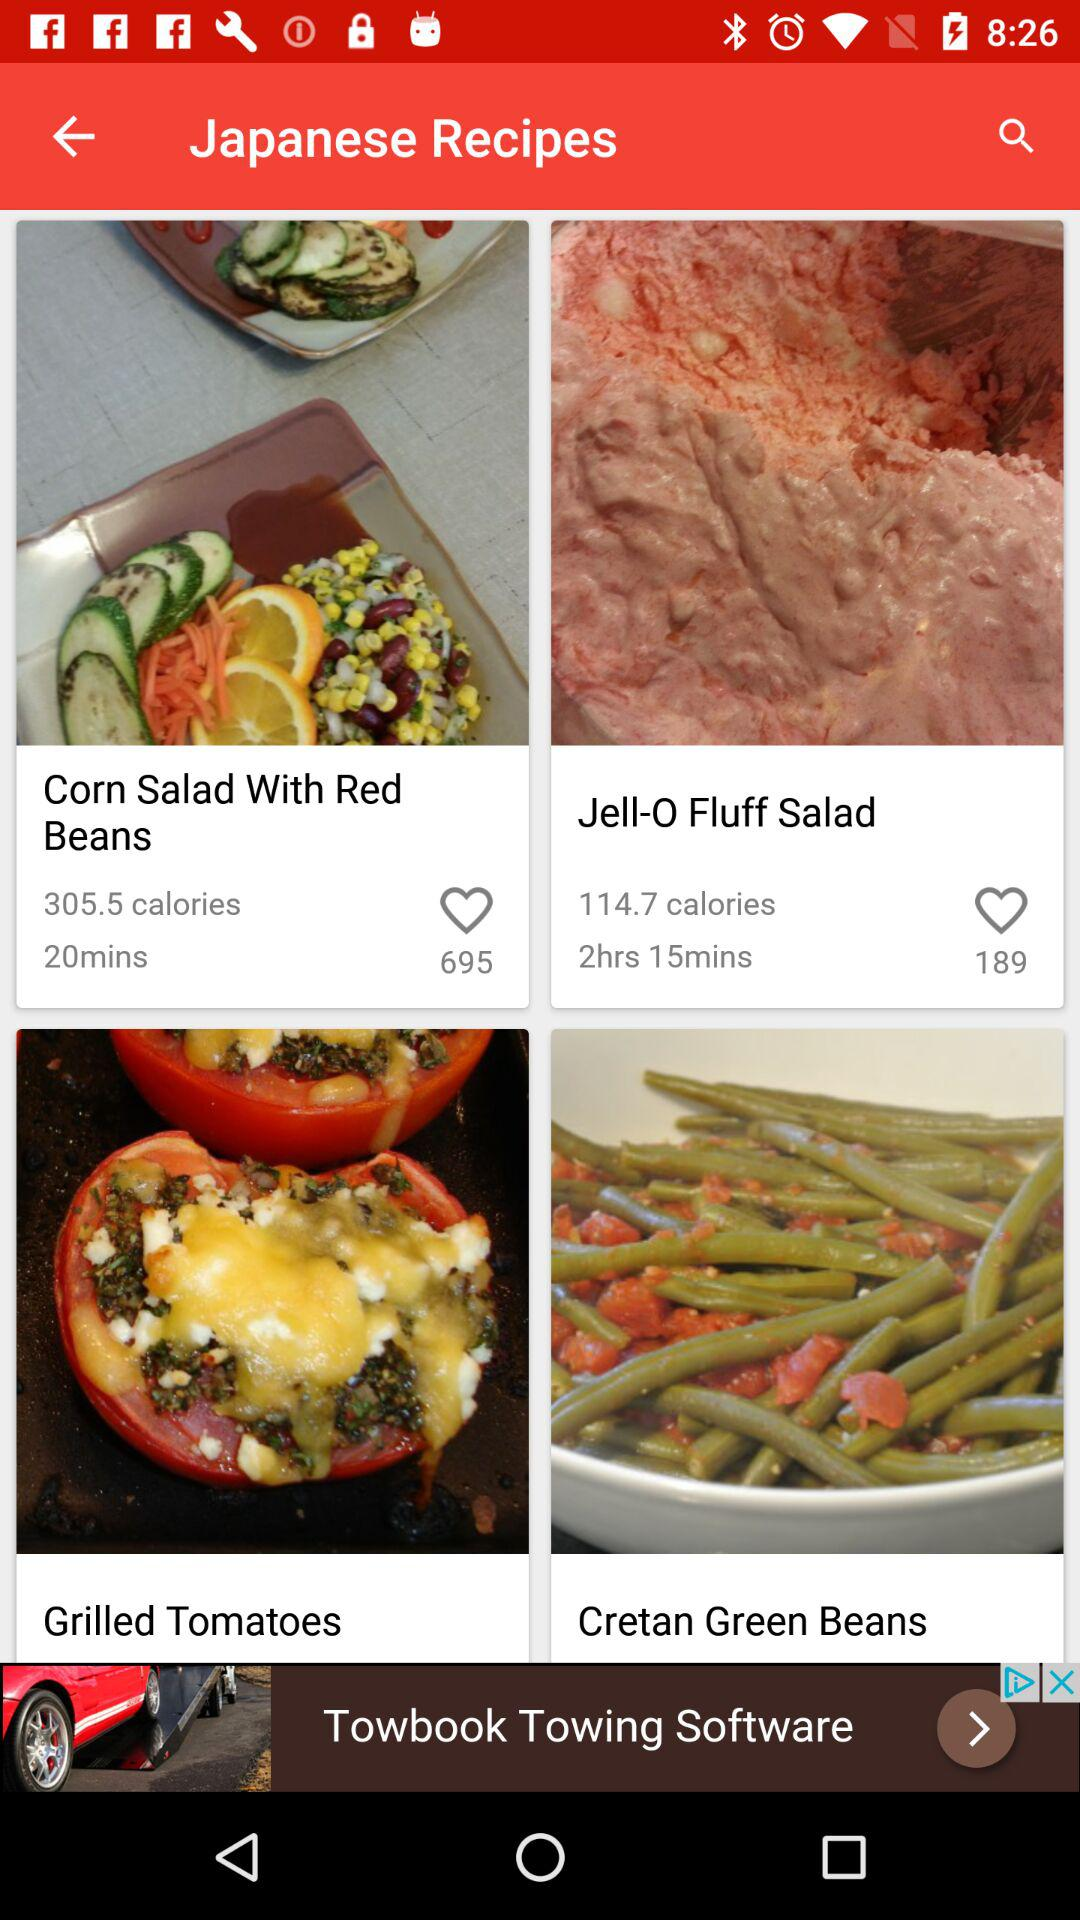How many likes are there for the recipe for "Jell-O Fluff Salad"? There are 189 likes. 